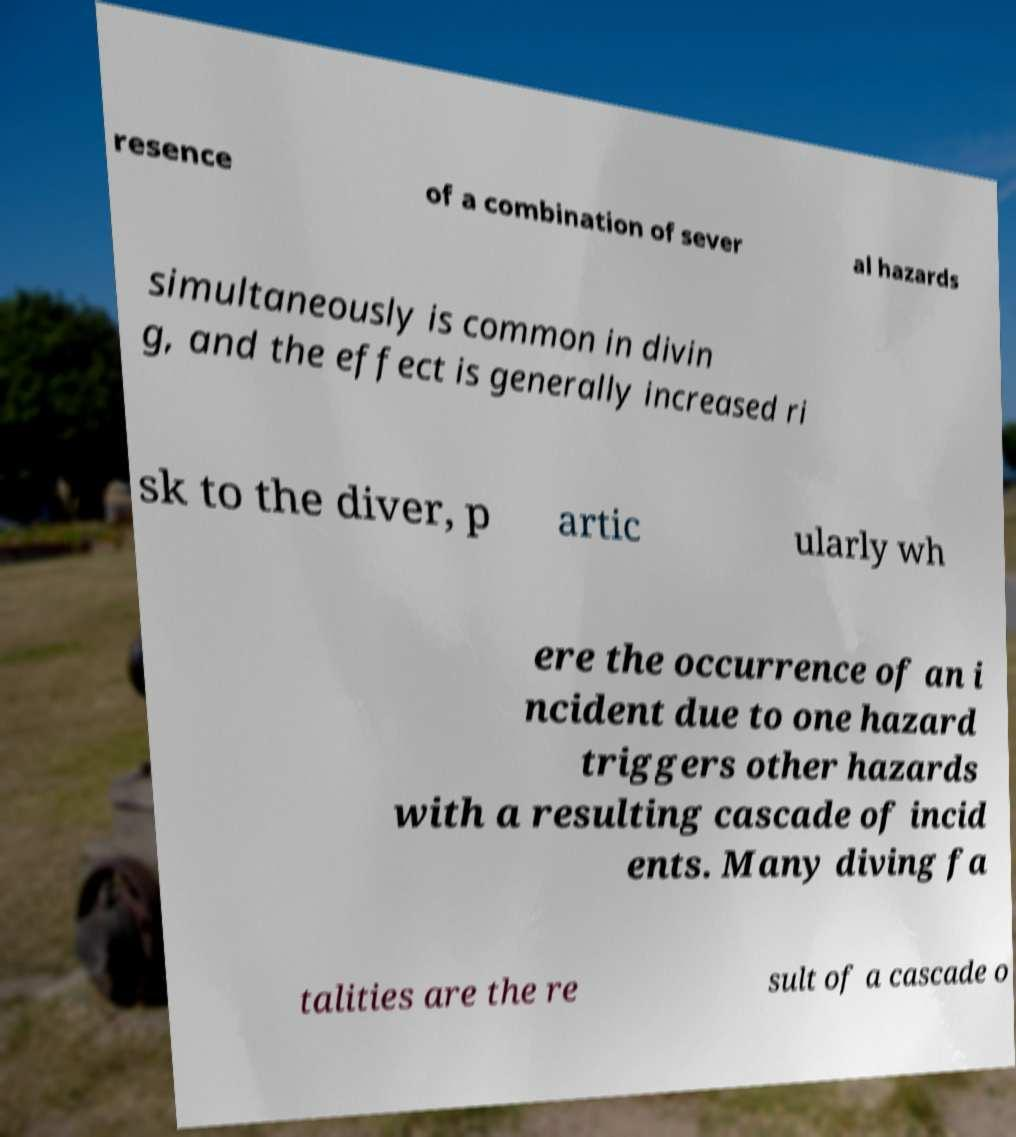I need the written content from this picture converted into text. Can you do that? resence of a combination of sever al hazards simultaneously is common in divin g, and the effect is generally increased ri sk to the diver, p artic ularly wh ere the occurrence of an i ncident due to one hazard triggers other hazards with a resulting cascade of incid ents. Many diving fa talities are the re sult of a cascade o 